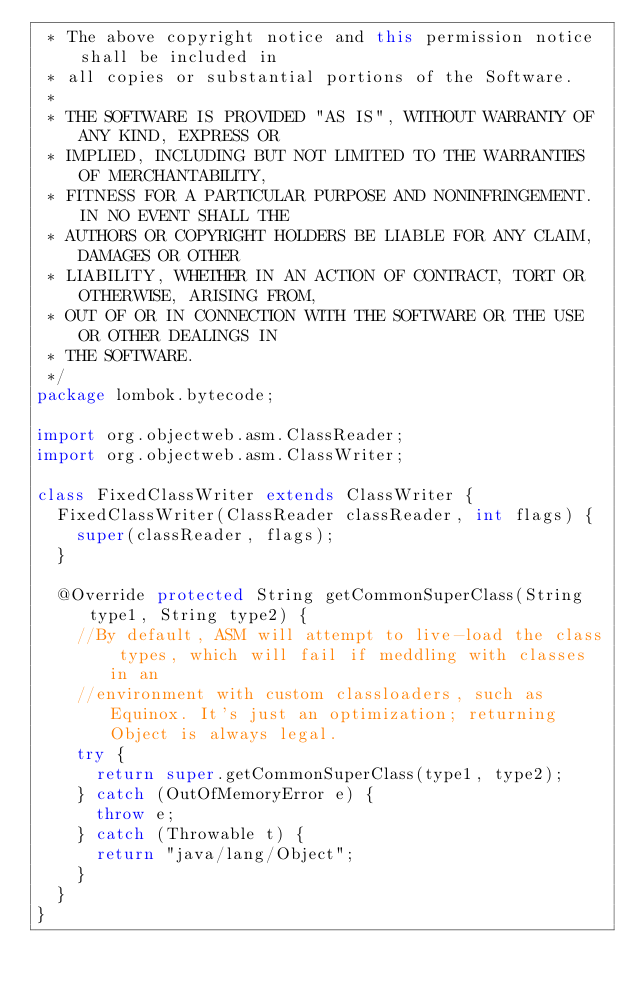Convert code to text. <code><loc_0><loc_0><loc_500><loc_500><_Java_> * The above copyright notice and this permission notice shall be included in
 * all copies or substantial portions of the Software.
 * 
 * THE SOFTWARE IS PROVIDED "AS IS", WITHOUT WARRANTY OF ANY KIND, EXPRESS OR
 * IMPLIED, INCLUDING BUT NOT LIMITED TO THE WARRANTIES OF MERCHANTABILITY,
 * FITNESS FOR A PARTICULAR PURPOSE AND NONINFRINGEMENT. IN NO EVENT SHALL THE
 * AUTHORS OR COPYRIGHT HOLDERS BE LIABLE FOR ANY CLAIM, DAMAGES OR OTHER
 * LIABILITY, WHETHER IN AN ACTION OF CONTRACT, TORT OR OTHERWISE, ARISING FROM,
 * OUT OF OR IN CONNECTION WITH THE SOFTWARE OR THE USE OR OTHER DEALINGS IN
 * THE SOFTWARE.
 */
package lombok.bytecode;

import org.objectweb.asm.ClassReader;
import org.objectweb.asm.ClassWriter;

class FixedClassWriter extends ClassWriter {
	FixedClassWriter(ClassReader classReader, int flags) {
		super(classReader, flags);
	}
	
	@Override protected String getCommonSuperClass(String type1, String type2) {
		//By default, ASM will attempt to live-load the class types, which will fail if meddling with classes in an
		//environment with custom classloaders, such as Equinox. It's just an optimization; returning Object is always legal.
		try {
			return super.getCommonSuperClass(type1, type2);
		} catch (OutOfMemoryError e) {
			throw e;
		} catch (Throwable t) {
			return "java/lang/Object";
		}
	}
}</code> 